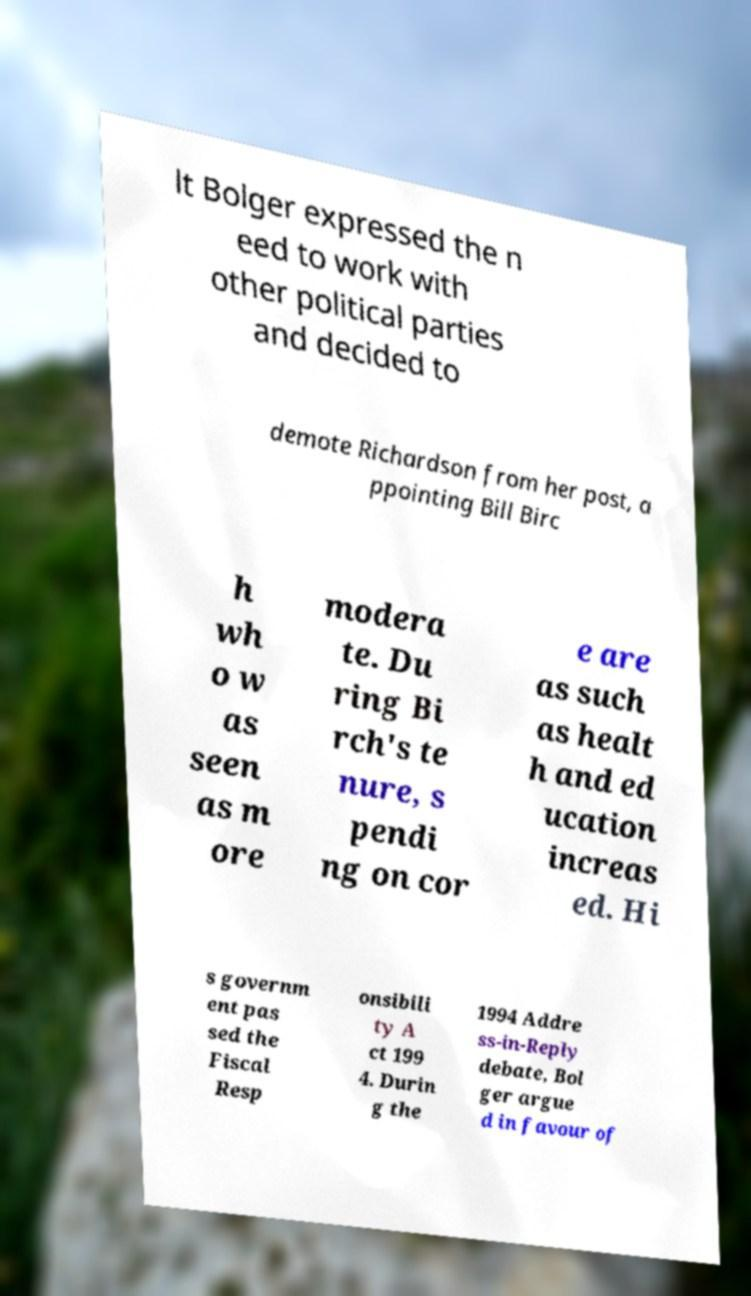Please identify and transcribe the text found in this image. lt Bolger expressed the n eed to work with other political parties and decided to demote Richardson from her post, a ppointing Bill Birc h wh o w as seen as m ore modera te. Du ring Bi rch's te nure, s pendi ng on cor e are as such as healt h and ed ucation increas ed. Hi s governm ent pas sed the Fiscal Resp onsibili ty A ct 199 4. Durin g the 1994 Addre ss-in-Reply debate, Bol ger argue d in favour of 